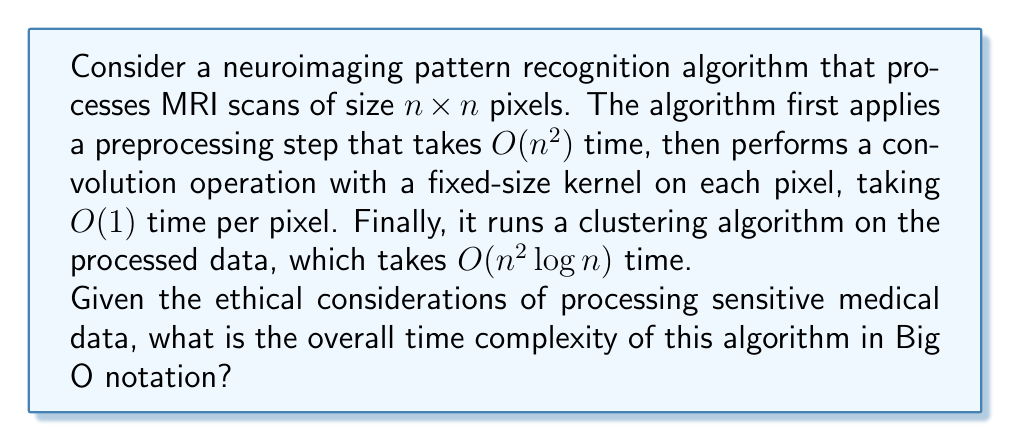Show me your answer to this math problem. To determine the overall time complexity, we need to consider each step of the algorithm:

1. Preprocessing step: $O(n^2)$
   This step processes each pixel in the $n \times n$ image once.

2. Convolution operation: $O(n^2)$
   The convolution is applied to each pixel, taking constant time per pixel. Since there are $n^2$ pixels, the total time is $O(n^2)$.

3. Clustering algorithm: $O(n^2 \log n)$
   This is the most complex step of the algorithm.

To find the overall time complexity, we add these components:

$$O(n^2) + O(n^2) + O(n^2 \log n)$$

Simplifying this expression:
- The two $O(n^2)$ terms can be combined into a single $O(n^2)$.
- $O(n^2 \log n)$ is asymptotically larger than $O(n^2)$.

Therefore, the overall time complexity is dominated by the clustering step:

$$O(n^2 \log n)$$

This result implies that as the size of the neuroimaging scans increases, the processing time will grow slightly faster than quadratically, which is an important consideration when dealing with large datasets of medical images.
Answer: $O(n^2 \log n)$ 